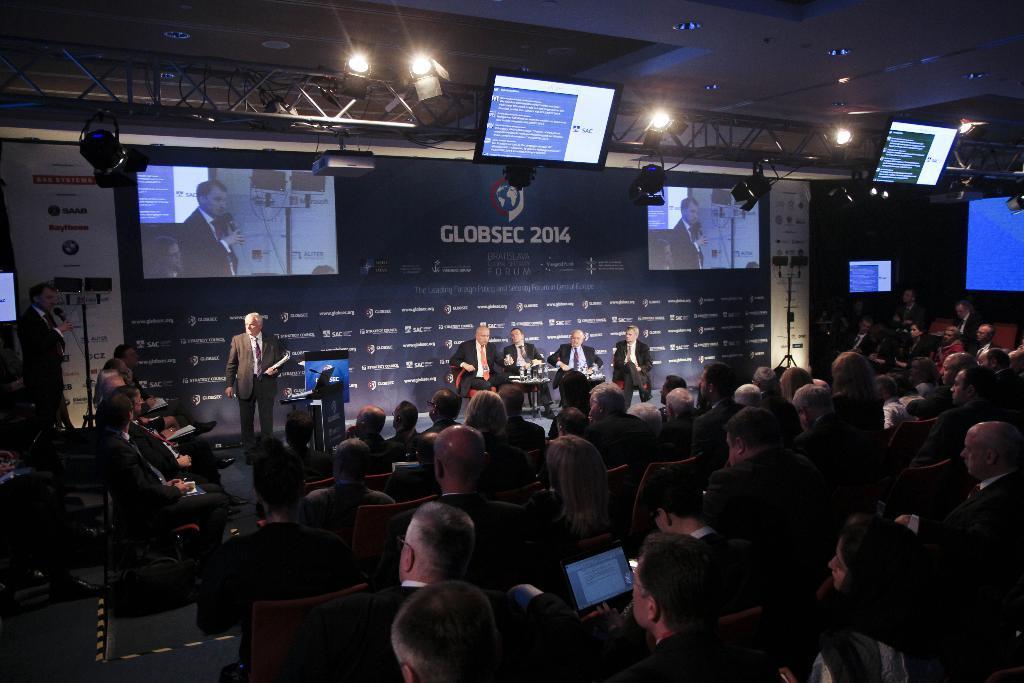Please provide a concise description of this image. In the image it looks like some meeting, there are a lot of people in the foreground of the image and in front of the people, few men are sitting on the chairs and behind them there is a huge banner, there are projectors displaying some video. There are two screens and in between the screens there are lights and there is a person standing on the left side, he is speaking something and behind him there are speakers. 